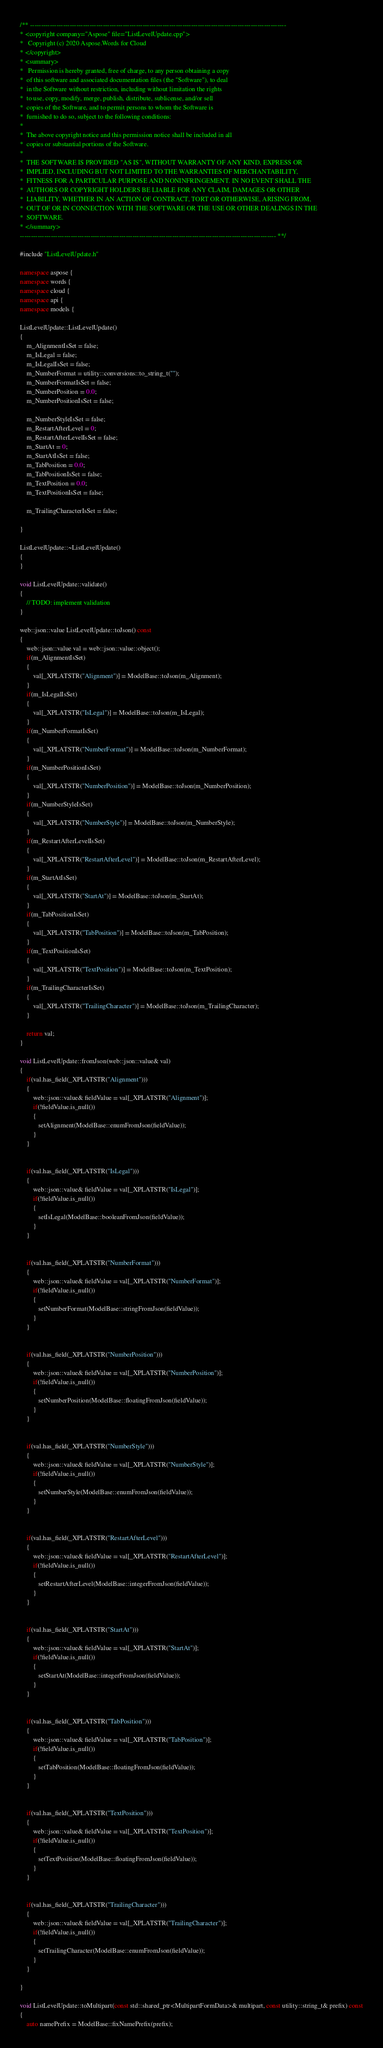Convert code to text. <code><loc_0><loc_0><loc_500><loc_500><_C++_>/** --------------------------------------------------------------------------------------------------------------------
* <copyright company="Aspose" file="ListLevelUpdate.cpp">
*   Copyright (c) 2020 Aspose.Words for Cloud
* </copyright>
* <summary>
*   Permission is hereby granted, free of charge, to any person obtaining a copy
*  of this software and associated documentation files (the "Software"), to deal
*  in the Software without restriction, including without limitation the rights
*  to use, copy, modify, merge, publish, distribute, sublicense, and/or sell
*  copies of the Software, and to permit persons to whom the Software is
*  furnished to do so, subject to the following conditions:
* 
*  The above copyright notice and this permission notice shall be included in all
*  copies or substantial portions of the Software.
* 
*  THE SOFTWARE IS PROVIDED "AS IS", WITHOUT WARRANTY OF ANY KIND, EXPRESS OR
*  IMPLIED, INCLUDING BUT NOT LIMITED TO THE WARRANTIES OF MERCHANTABILITY,
*  FITNESS FOR A PARTICULAR PURPOSE AND NONINFRINGEMENT. IN NO EVENT SHALL THE
*  AUTHORS OR COPYRIGHT HOLDERS BE LIABLE FOR ANY CLAIM, DAMAGES OR OTHER
*  LIABILITY, WHETHER IN AN ACTION OF CONTRACT, TORT OR OTHERWISE, ARISING FROM,
*  OUT OF OR IN CONNECTION WITH THE SOFTWARE OR THE USE OR OTHER DEALINGS IN THE
*  SOFTWARE.
* </summary> 
-------------------------------------------------------------------------------------------------------------------- **/

#include "ListLevelUpdate.h"

namespace aspose {
namespace words {
namespace cloud {
namespace api {
namespace models {

ListLevelUpdate::ListLevelUpdate()
{
    m_AlignmentIsSet = false;
    m_IsLegal = false;
    m_IsLegalIsSet = false;
    m_NumberFormat = utility::conversions::to_string_t("");
    m_NumberFormatIsSet = false;
    m_NumberPosition = 0.0;
    m_NumberPositionIsSet = false;

    m_NumberStyleIsSet = false;
    m_RestartAfterLevel = 0;
    m_RestartAfterLevelIsSet = false;
    m_StartAt = 0;
    m_StartAtIsSet = false;
    m_TabPosition = 0.0;
    m_TabPositionIsSet = false;
    m_TextPosition = 0.0;
    m_TextPositionIsSet = false;

    m_TrailingCharacterIsSet = false;

}

ListLevelUpdate::~ListLevelUpdate()
{
}

void ListLevelUpdate::validate()
{
    // TODO: implement validation
}

web::json::value ListLevelUpdate::toJson() const
{
    web::json::value val = web::json::value::object();
    if(m_AlignmentIsSet)
    {
        val[_XPLATSTR("Alignment")] = ModelBase::toJson(m_Alignment);
    }
    if(m_IsLegalIsSet)
    {
        val[_XPLATSTR("IsLegal")] = ModelBase::toJson(m_IsLegal);
    }
    if(m_NumberFormatIsSet)
    {
        val[_XPLATSTR("NumberFormat")] = ModelBase::toJson(m_NumberFormat);
    }
    if(m_NumberPositionIsSet)
    {
        val[_XPLATSTR("NumberPosition")] = ModelBase::toJson(m_NumberPosition);
    }
    if(m_NumberStyleIsSet)
    {
        val[_XPLATSTR("NumberStyle")] = ModelBase::toJson(m_NumberStyle);
    }
    if(m_RestartAfterLevelIsSet)
    {
        val[_XPLATSTR("RestartAfterLevel")] = ModelBase::toJson(m_RestartAfterLevel);
    }
    if(m_StartAtIsSet)
    {
        val[_XPLATSTR("StartAt")] = ModelBase::toJson(m_StartAt);
    }
    if(m_TabPositionIsSet)
    {
        val[_XPLATSTR("TabPosition")] = ModelBase::toJson(m_TabPosition);
    }
    if(m_TextPositionIsSet)
    {
        val[_XPLATSTR("TextPosition")] = ModelBase::toJson(m_TextPosition);
    }
    if(m_TrailingCharacterIsSet)
    {
        val[_XPLATSTR("TrailingCharacter")] = ModelBase::toJson(m_TrailingCharacter);
    }

    return val;
}

void ListLevelUpdate::fromJson(web::json::value& val)
{
    if(val.has_field(_XPLATSTR("Alignment")))
    {
        web::json::value& fieldValue = val[_XPLATSTR("Alignment")];
        if(!fieldValue.is_null())
        {
           setAlignment(ModelBase::enumFromJson(fieldValue));
        }
    }


    if(val.has_field(_XPLATSTR("IsLegal")))
    {
        web::json::value& fieldValue = val[_XPLATSTR("IsLegal")];
        if(!fieldValue.is_null())
        {
           setIsLegal(ModelBase::booleanFromJson(fieldValue));
        }
    }


    if(val.has_field(_XPLATSTR("NumberFormat")))
    {
        web::json::value& fieldValue = val[_XPLATSTR("NumberFormat")];
        if(!fieldValue.is_null())
        {
           setNumberFormat(ModelBase::stringFromJson(fieldValue));
        }
    }


    if(val.has_field(_XPLATSTR("NumberPosition")))
    {
        web::json::value& fieldValue = val[_XPLATSTR("NumberPosition")];
        if(!fieldValue.is_null())
        {
           setNumberPosition(ModelBase::floatingFromJson(fieldValue));
        }
    }


    if(val.has_field(_XPLATSTR("NumberStyle")))
    {
        web::json::value& fieldValue = val[_XPLATSTR("NumberStyle")];
        if(!fieldValue.is_null())
        {
           setNumberStyle(ModelBase::enumFromJson(fieldValue));
        }
    }


    if(val.has_field(_XPLATSTR("RestartAfterLevel")))
    {
        web::json::value& fieldValue = val[_XPLATSTR("RestartAfterLevel")];
        if(!fieldValue.is_null())
        {
           setRestartAfterLevel(ModelBase::integerFromJson(fieldValue));
        }
    }


    if(val.has_field(_XPLATSTR("StartAt")))
    {
        web::json::value& fieldValue = val[_XPLATSTR("StartAt")];
        if(!fieldValue.is_null())
        {
           setStartAt(ModelBase::integerFromJson(fieldValue));
        }
    }


    if(val.has_field(_XPLATSTR("TabPosition")))
    {
        web::json::value& fieldValue = val[_XPLATSTR("TabPosition")];
        if(!fieldValue.is_null())
        {
           setTabPosition(ModelBase::floatingFromJson(fieldValue));
        }
    }


    if(val.has_field(_XPLATSTR("TextPosition")))
    {
        web::json::value& fieldValue = val[_XPLATSTR("TextPosition")];
        if(!fieldValue.is_null())
        {
           setTextPosition(ModelBase::floatingFromJson(fieldValue));
        }
    }


    if(val.has_field(_XPLATSTR("TrailingCharacter")))
    {
        web::json::value& fieldValue = val[_XPLATSTR("TrailingCharacter")];
        if(!fieldValue.is_null())
        {
           setTrailingCharacter(ModelBase::enumFromJson(fieldValue));
        }
    }

}

void ListLevelUpdate::toMultipart(const std::shared_ptr<MultipartFormData>& multipart, const utility::string_t& prefix) const
{
    auto namePrefix = ModelBase::fixNamePrefix(prefix);</code> 